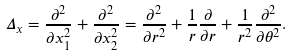<formula> <loc_0><loc_0><loc_500><loc_500>\Delta _ { x } = \frac { \partial ^ { 2 } } { \partial x _ { 1 } ^ { 2 } } + \frac { \partial ^ { 2 } } { \partial x _ { 2 } ^ { 2 } } = \frac { \partial ^ { 2 } } { \partial r ^ { 2 } } + \frac { 1 } { r } \frac { \partial } { \partial r } + \frac { 1 } { r ^ { 2 } } \frac { \partial ^ { 2 } } { \partial \theta ^ { 2 } } .</formula> 